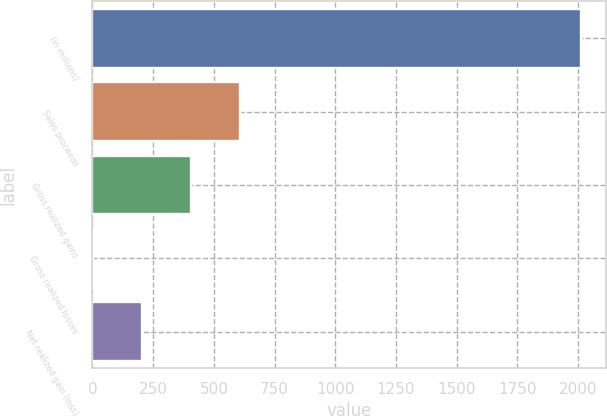<chart> <loc_0><loc_0><loc_500><loc_500><bar_chart><fcel>(in millions)<fcel>Sales proceeds<fcel>Gross realized gains<fcel>Gross realized losses<fcel>Net realized gain (loss)<nl><fcel>2014<fcel>606.3<fcel>405.2<fcel>3<fcel>204.1<nl></chart> 